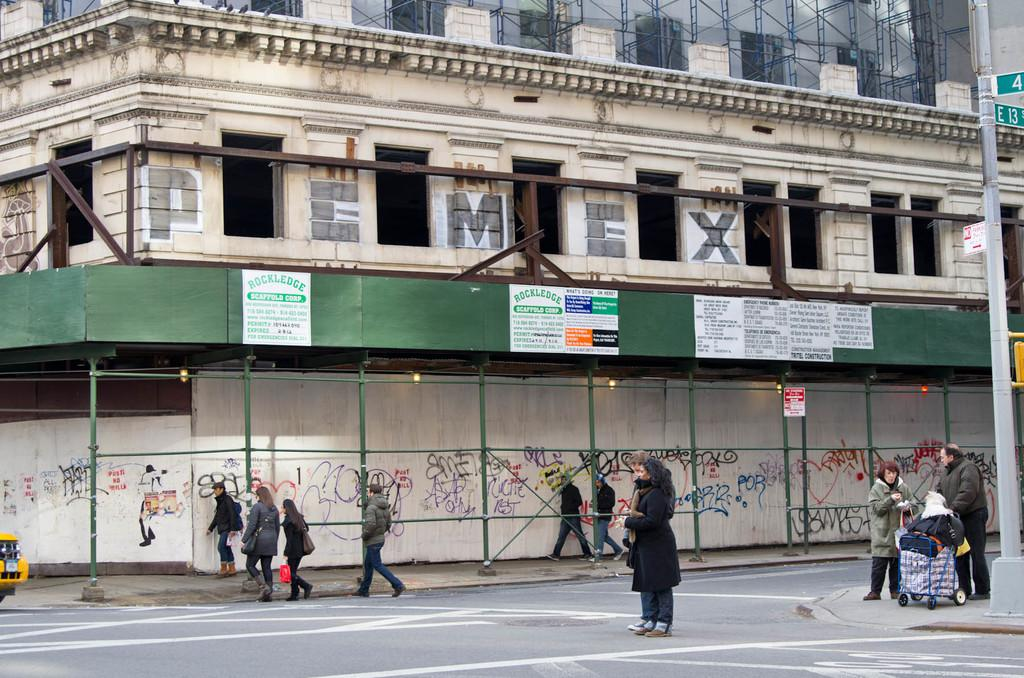<image>
Give a short and clear explanation of the subsequent image. A building has PEMEX spelled in the upper stonework and has graffitied scaffolding on street level provided by Rockledge Scaffold Corp. 